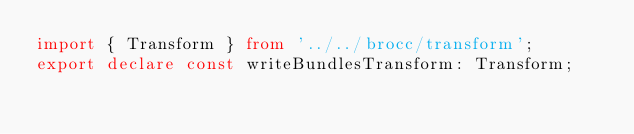Convert code to text. <code><loc_0><loc_0><loc_500><loc_500><_TypeScript_>import { Transform } from '../../brocc/transform';
export declare const writeBundlesTransform: Transform;
</code> 